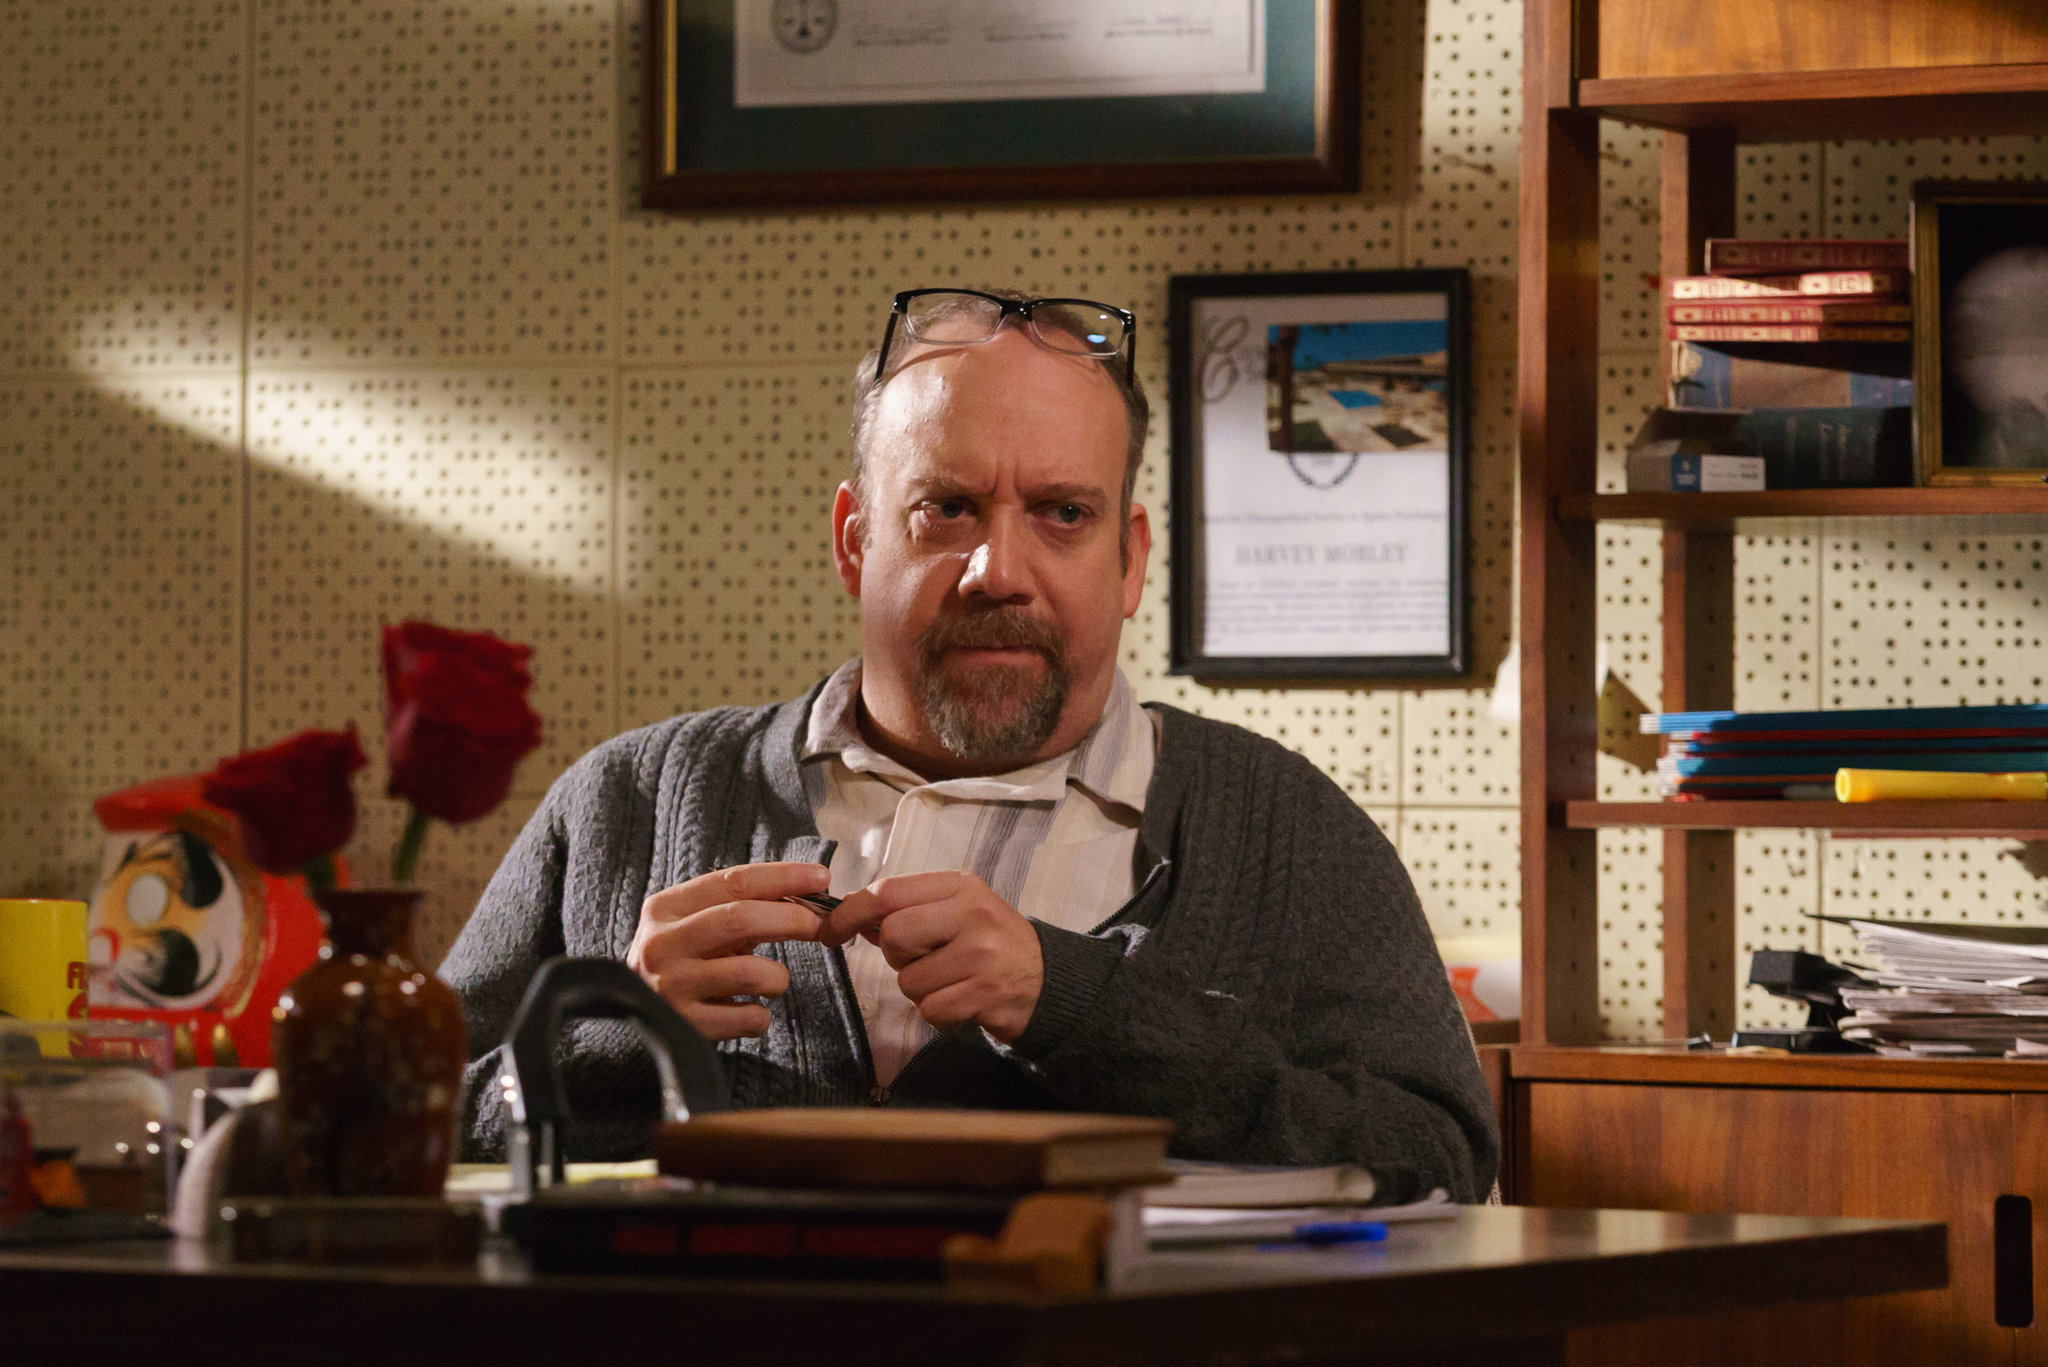Describe the possible daily routine of the man in the image. The daily routine of the man in the image likely starts early with a sense of determination. He might begin his day with a strong cup of coffee, immediately diving into his work. His mornings could be spent absorbed in reading, writing, or reviewing important documents, given the clutter on his desk. Around midday, he might take a short break to gather his thoughts or have a brief meal, before returning to his work with renewed vigor. Afternoons might be filled with meetings, consultations, or intensive research sessions. As the day progresses, the man might maintain his focus well into the evening, only pausing to take sips from his coffee mug, immersed in a cycle of continuous intellectual engagement and productivity. His dedication and intensity suggest long working hours, possibly ending late at night when he finally allows himself a moment to unwind. 